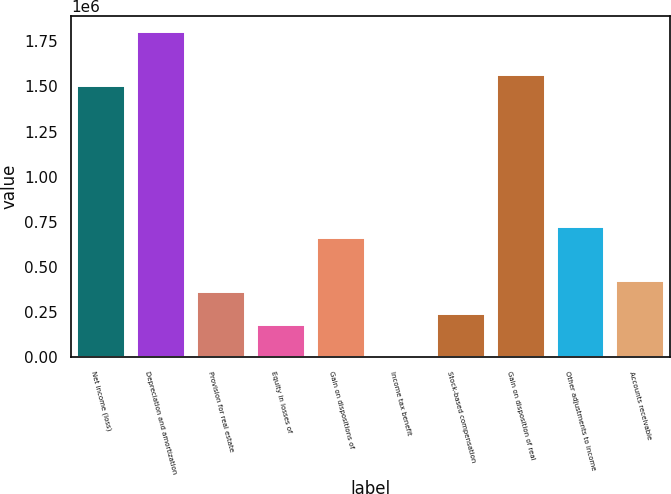Convert chart to OTSL. <chart><loc_0><loc_0><loc_500><loc_500><bar_chart><fcel>Net income (loss)<fcel>Depreciation and amortization<fcel>Provision for real estate<fcel>Equity in losses of<fcel>Gain on dispositions of<fcel>Income tax benefit<fcel>Stock-based compensation<fcel>Gain on disposition of real<fcel>Other adjustments to income<fcel>Accounts receivable<nl><fcel>1.50095e+06<fcel>1.80096e+06<fcel>360934<fcel>180932<fcel>660939<fcel>929<fcel>240933<fcel>1.56095e+06<fcel>720940<fcel>420935<nl></chart> 